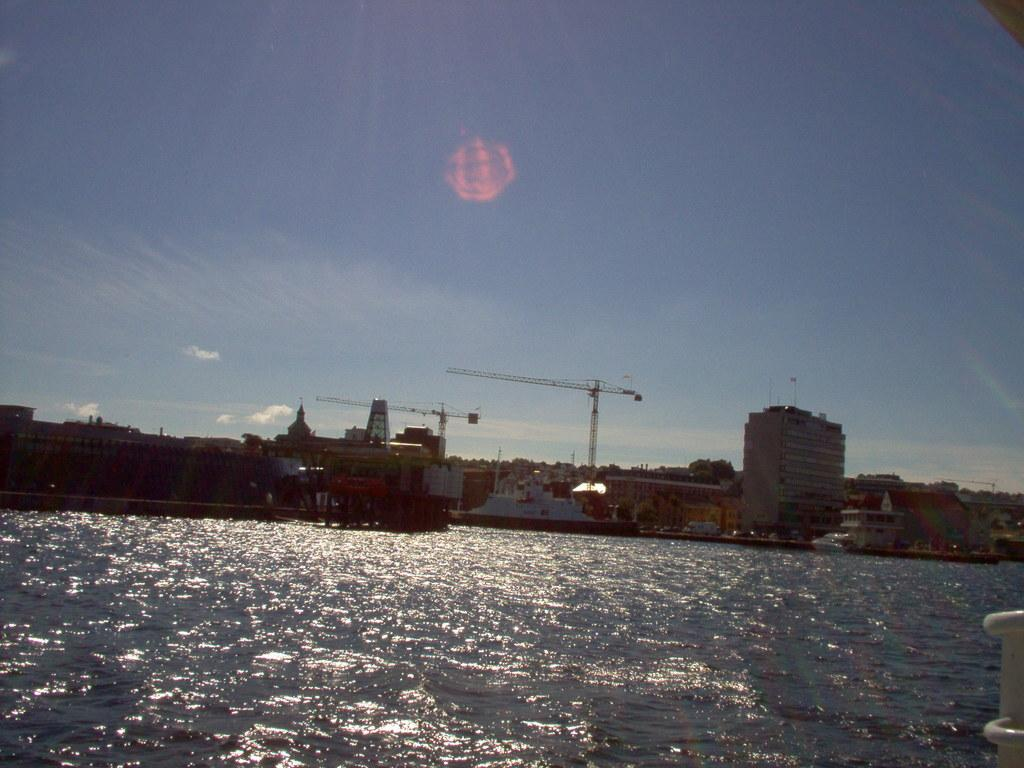What type of structures are present in the image? There is a group of buildings in the image. What equipment can be seen in the image? There are two metal cranes in the image. What is visible in the foreground of the image? There is water visible in the foreground of the image. What is visible in the background of the image? The sky is visible in the background of the image. How would you describe the sky in the image? The sky appears to be cloudy in the image. What type of stitch is used to sew the trousers in the image? There are no trousers present in the image; it features a group of buildings, metal cranes, water, and a cloudy sky. What is the range of the metal cranes in the image? The range of the metal cranes cannot be determined from the image alone, as it does not provide information about their capabilities or limitations. 